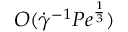<formula> <loc_0><loc_0><loc_500><loc_500>O ( \dot { \gamma } ^ { - 1 } P e ^ { \frac { 1 } { 3 } } )</formula> 